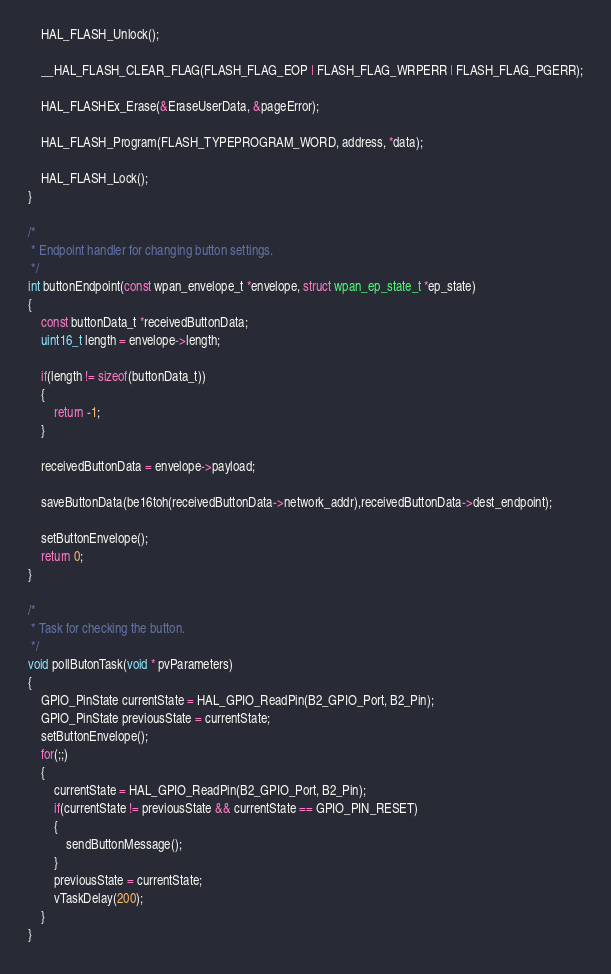<code> <loc_0><loc_0><loc_500><loc_500><_C_>	HAL_FLASH_Unlock();

	__HAL_FLASH_CLEAR_FLAG(FLASH_FLAG_EOP | FLASH_FLAG_WRPERR | FLASH_FLAG_PGERR);

	HAL_FLASHEx_Erase(&EraseUserData, &pageError);

	HAL_FLASH_Program(FLASH_TYPEPROGRAM_WORD, address, *data);

	HAL_FLASH_Lock();
}

/*
 * Endpoint handler for changing button settings.
 */
int buttonEndpoint(const wpan_envelope_t *envelope, struct wpan_ep_state_t *ep_state)
{
	const buttonData_t *receivedButtonData;
	uint16_t length = envelope->length;

	if(length != sizeof(buttonData_t))
	{
		return -1;
	}

	receivedButtonData = envelope->payload;

	saveButtonData(be16toh(receivedButtonData->network_addr),receivedButtonData->dest_endpoint);

	setButtonEnvelope();
	return 0;
}

/*
 * Task for checking the button.
 */
void pollButonTask(void * pvParameters)
{
	GPIO_PinState currentState = HAL_GPIO_ReadPin(B2_GPIO_Port, B2_Pin);
	GPIO_PinState previousState = currentState;
	setButtonEnvelope();
	for(;;)
	{
		currentState = HAL_GPIO_ReadPin(B2_GPIO_Port, B2_Pin);
		if(currentState != previousState && currentState == GPIO_PIN_RESET)
		{
			sendButtonMessage();
		}
		previousState = currentState;
		vTaskDelay(200);
	}
}
</code> 